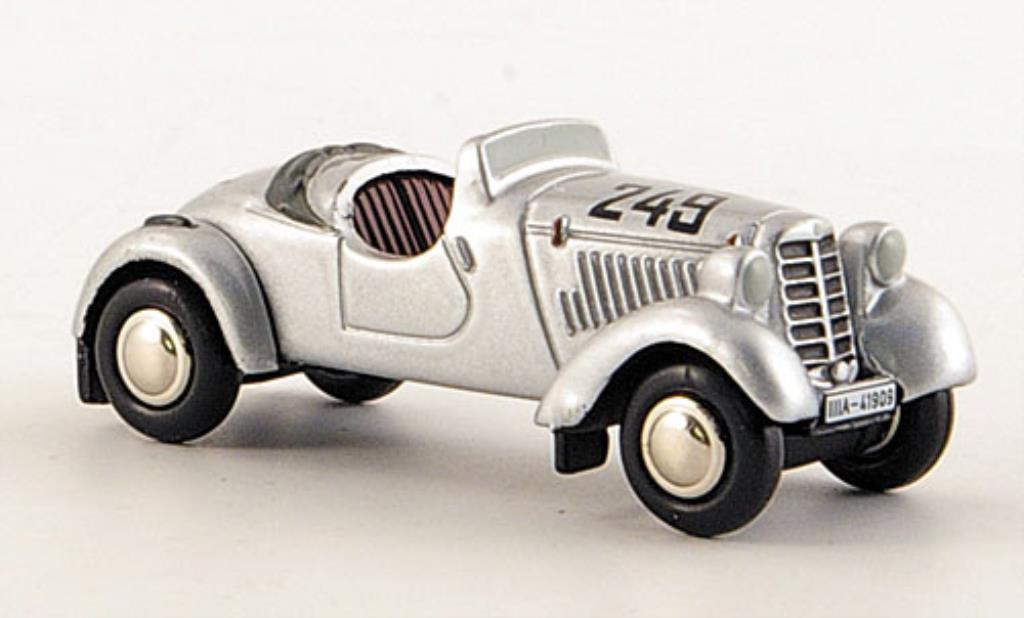Imagine this car was recently restored and is being taken for a brief test drive. Describe that scene. The recently restored race car fired up with a throaty growl, its engine purring like new. The mechanic, smiling proudly, took it for a gentle test drive down the quiet countryside lanes. The car's polished body shimmered under the sunlight, and every detail, from the number '243' to the 'IA-1935' code, looked pristine. As it glided effortlessly on the road, it felt both a nostalgic journey and a celebration of craftsmanship. Passersby turned their heads, captivated by the timeless beauty and the unmistakable spirit of a classic brought back to life. 